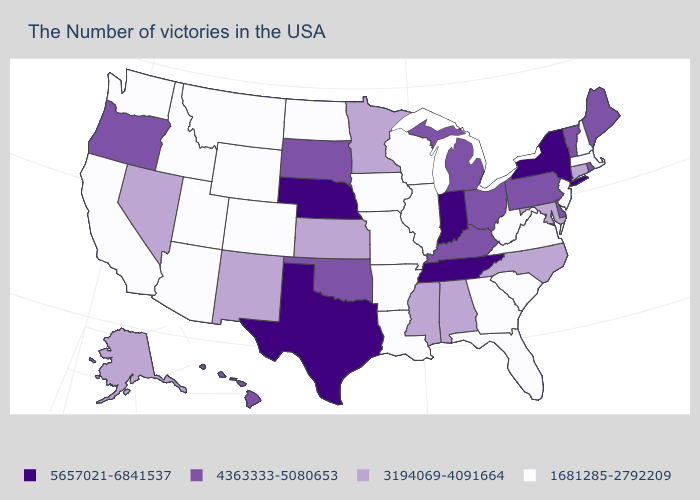Among the states that border Utah , does Nevada have the highest value?
Write a very short answer. Yes. Name the states that have a value in the range 1681285-2792209?
Give a very brief answer. Massachusetts, New Hampshire, New Jersey, Virginia, South Carolina, West Virginia, Florida, Georgia, Wisconsin, Illinois, Louisiana, Missouri, Arkansas, Iowa, North Dakota, Wyoming, Colorado, Utah, Montana, Arizona, Idaho, California, Washington. Which states have the lowest value in the USA?
Answer briefly. Massachusetts, New Hampshire, New Jersey, Virginia, South Carolina, West Virginia, Florida, Georgia, Wisconsin, Illinois, Louisiana, Missouri, Arkansas, Iowa, North Dakota, Wyoming, Colorado, Utah, Montana, Arizona, Idaho, California, Washington. What is the value of West Virginia?
Be succinct. 1681285-2792209. Is the legend a continuous bar?
Write a very short answer. No. Name the states that have a value in the range 5657021-6841537?
Quick response, please. New York, Indiana, Tennessee, Nebraska, Texas. Does Arizona have the lowest value in the West?
Give a very brief answer. Yes. Does Illinois have a lower value than Hawaii?
Give a very brief answer. Yes. Among the states that border Kentucky , does West Virginia have the lowest value?
Write a very short answer. Yes. Which states have the highest value in the USA?
Concise answer only. New York, Indiana, Tennessee, Nebraska, Texas. Does Virginia have a lower value than Nebraska?
Quick response, please. Yes. Name the states that have a value in the range 5657021-6841537?
Keep it brief. New York, Indiana, Tennessee, Nebraska, Texas. Does California have a higher value than Oregon?
Concise answer only. No. Does Colorado have the lowest value in the USA?
Keep it brief. Yes. Does the map have missing data?
Short answer required. No. 